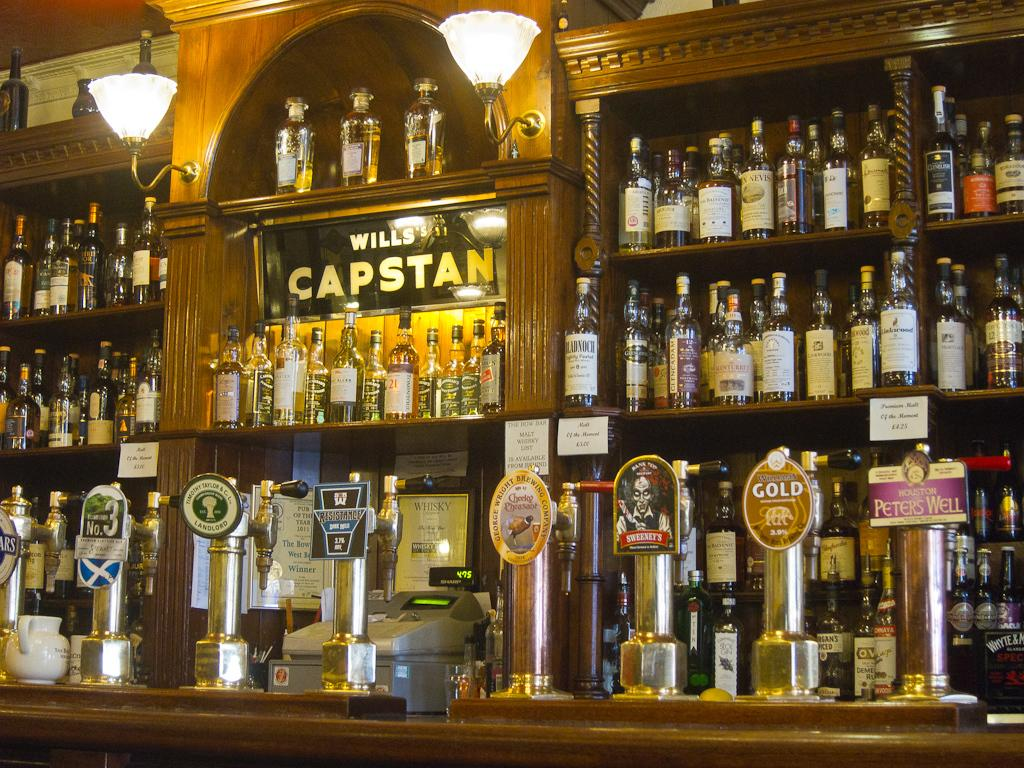<image>
Render a clear and concise summary of the photo. A bar with shelves of liquor with a sign hanging on the wall dividing the shelves which says Will's Captain. 